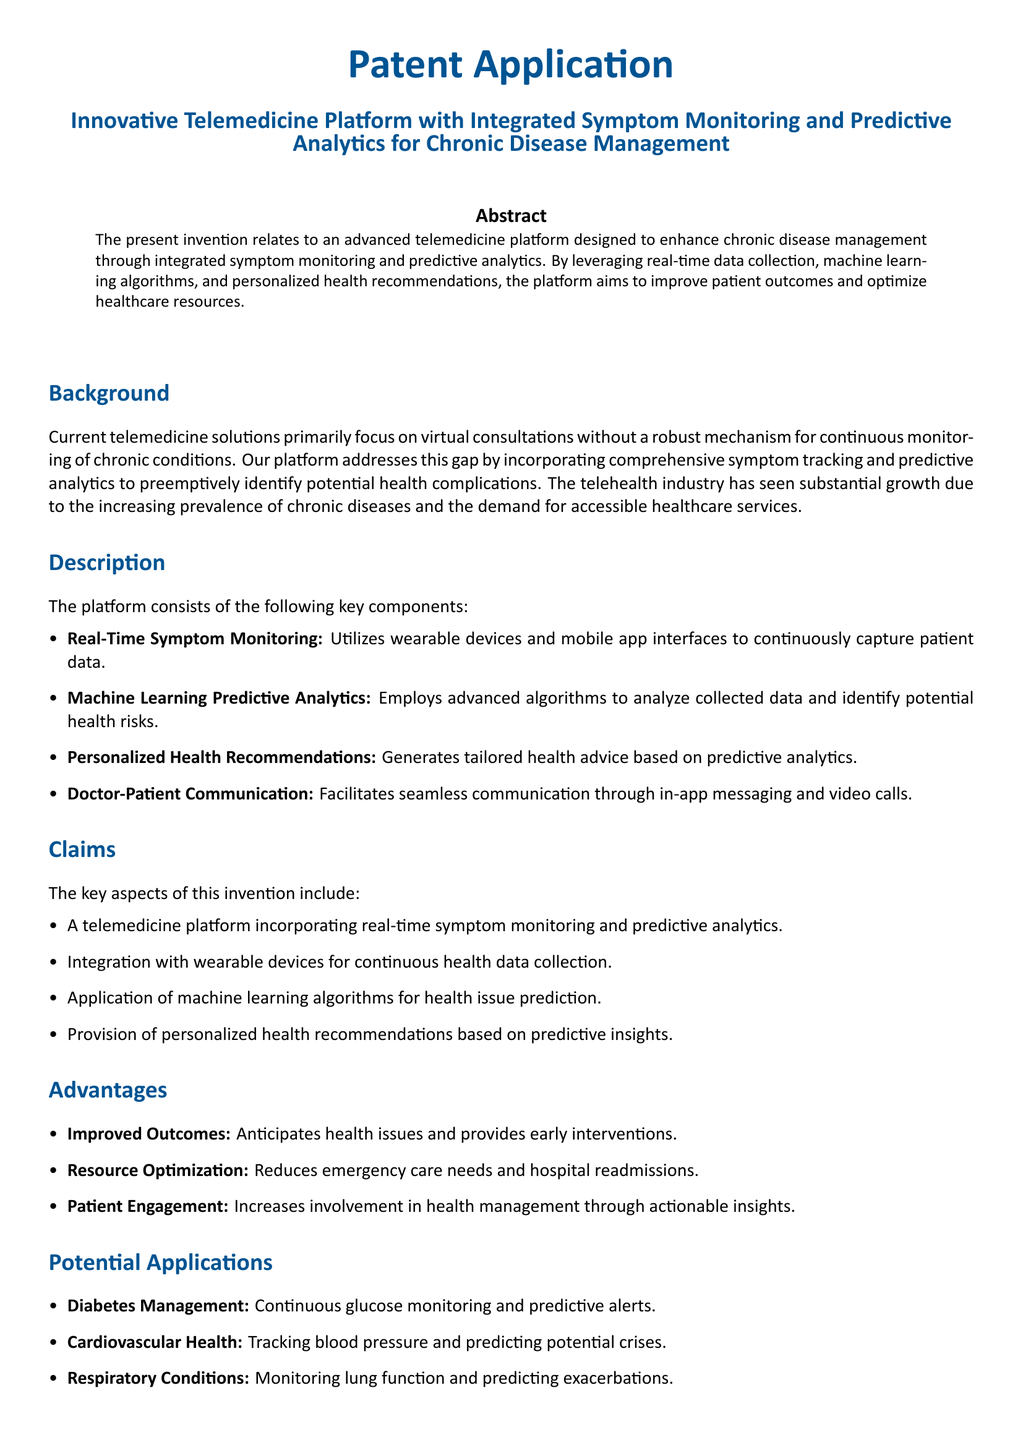What is the title of the patent application? The title of the patent application is stated in the document's header section.
Answer: Innovative Telemedicine Platform with Integrated Symptom Monitoring and Predictive Analytics for Chronic Disease Management What is the main objective of the invention? The abstract specifies that the main objective is to enhance chronic disease management.
Answer: Enhance chronic disease management What are the key components of the platform? The description section lists the main features, which also highlight the uniqueness of the invention.
Answer: Real-Time Symptom Monitoring, Machine Learning Predictive Analytics, Personalized Health Recommendations, Doctor-Patient Communication What type of analytics is employed in the platform? The description mentions the specific technology used to analyze patient data.
Answer: Machine Learning Predictive Analytics Which chronic disease management application is mentioned in the document? The potential applications section illustrates specific conditions where the platform can be beneficial.
Answer: Diabetes Management What advantage does the platform provide regarding emergency care? The advantages listed in the document explain how the platform impacts healthcare outcomes.
Answer: Reduces emergency care needs What method does the platform use to anticipate health issues? The document explains how the platform identifies potential health risks.
Answer: Advanced algorithms What is the focus of the current telemedicine solutions according to the background? The background section addresses what existing telemedicine solutions primarily achieve.
Answer: Virtual consultations How does the platform enhance patient engagement? The advantages outline how the platform impacts patient involvement in healthcare.
Answer: Increases involvement in health management through actionable insights What integration features does the platform possess? The claims section specifies how the platform connects with other technologies.
Answer: Integration with wearable devices 